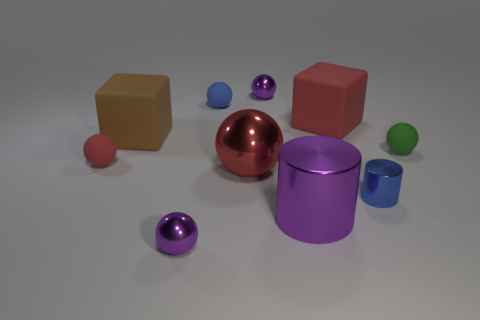Subtract all small purple balls. How many balls are left? 4 Subtract all green cylinders. How many red balls are left? 2 Subtract all blue balls. How many balls are left? 5 Subtract all spheres. How many objects are left? 4 Subtract all green cylinders. Subtract all blue balls. How many cylinders are left? 2 Add 2 small blue cylinders. How many small blue cylinders are left? 3 Add 1 cyan metal cylinders. How many cyan metal cylinders exist? 1 Subtract 1 blue cylinders. How many objects are left? 9 Subtract all large red shiny cubes. Subtract all big metallic objects. How many objects are left? 8 